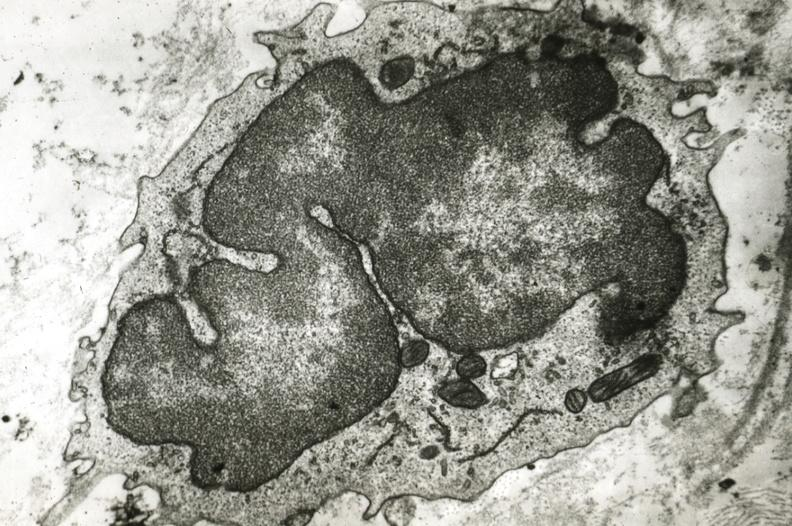does this image show monocyte in intima?
Answer the question using a single word or phrase. Yes 